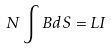Convert formula to latex. <formula><loc_0><loc_0><loc_500><loc_500>N \int B d S = L I</formula> 